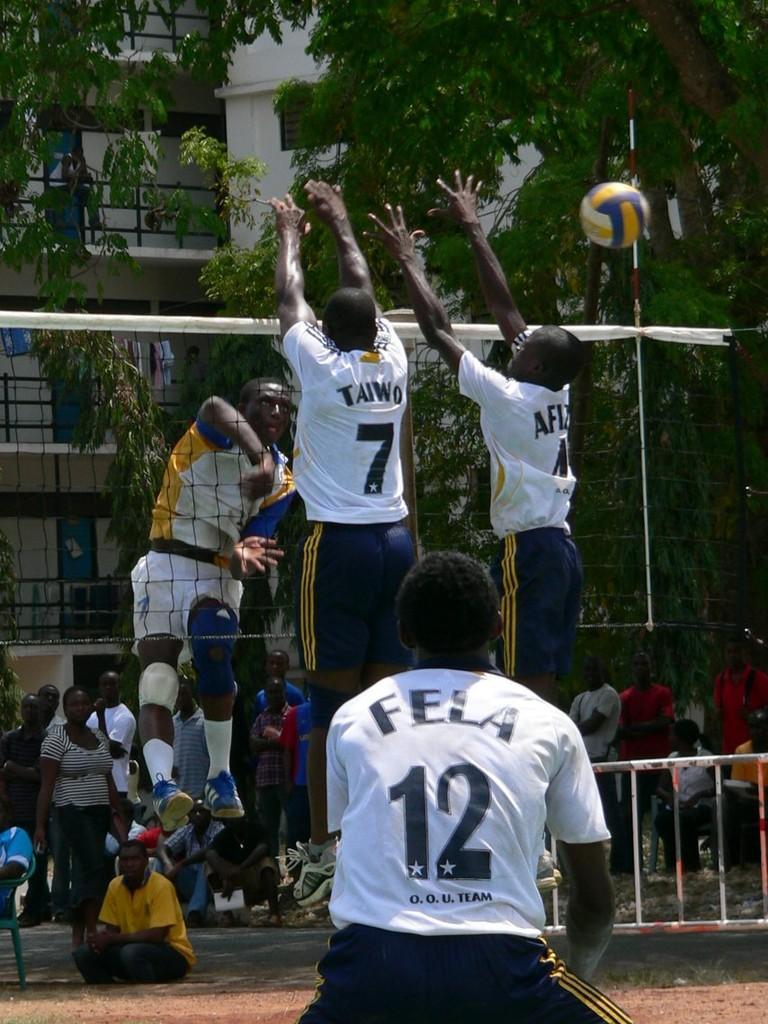Please provide a concise description of this image. In the middle of the image there is a man with white t-shirt and black short is standing. In front of him there are two persons with white t-shirts is in the air. In front of them there is a net. Behind the net there are two persons in the air. In the background there are few people standing and few people are sitting on the ground. And also there are many trees. Behind the trees there is a white color building with railings and doors. 